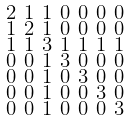<formula> <loc_0><loc_0><loc_500><loc_500>\begin{smallmatrix} 2 & 1 & 1 & 0 & 0 & 0 & 0 \\ 1 & 2 & 1 & 0 & 0 & 0 & 0 \\ 1 & 1 & 3 & 1 & 1 & 1 & 1 \\ 0 & 0 & 1 & 3 & 0 & 0 & 0 \\ 0 & 0 & 1 & 0 & 3 & 0 & 0 \\ 0 & 0 & 1 & 0 & 0 & 3 & 0 \\ 0 & 0 & 1 & 0 & 0 & 0 & 3 \end{smallmatrix}</formula> 